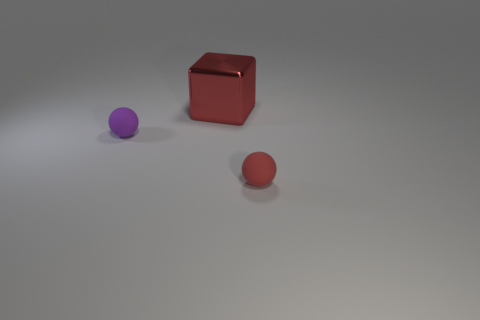Add 3 red rubber balls. How many objects exist? 6 Subtract all balls. How many objects are left? 1 Subtract 0 gray cubes. How many objects are left? 3 Subtract all big cyan things. Subtract all tiny balls. How many objects are left? 1 Add 2 metal objects. How many metal objects are left? 3 Add 2 blue cylinders. How many blue cylinders exist? 2 